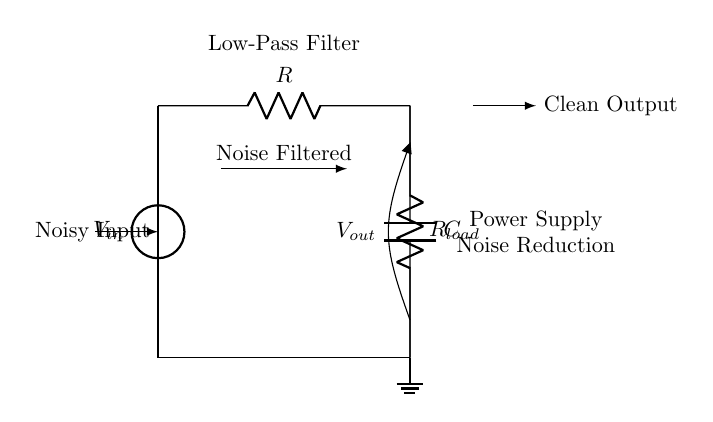What type of filter is this circuit? The circuit is labeled as a low-pass filter, which indicates that it allows low-frequency signals to pass while attenuating higher frequencies.
Answer: Low-pass filter What does "R" represent in the circuit? The "R" symbol in the circuit diagram stands for a resistor, which limits the current flow and helps in forming the filter.
Answer: Resistor What is the purpose of the capacitor "C" in this circuit? The capacitor "C" in a low-pass filter stores and releases electrical energy, smoothing out short-term fluctuations in voltage and reducing noise.
Answer: Noise reduction What is the role of "R_load" in this circuit? "R_load" serves as the load resistor, which represents the component that is powered by the filtered output voltage from the low-pass filter.
Answer: Load resistor Which component provides the input voltage to the circuit? The component providing the input voltage is labeled as "V_in," indicating it is the source supplying the voltage to the filter circuit.
Answer: V_in How does the output voltage "V_out" relate to the input voltage "V_in"? The output voltage "V_out" is the voltage after passing through the low-pass filter, ideally having less high-frequency noise compared to "V_in".
Answer: Cleaner voltage 